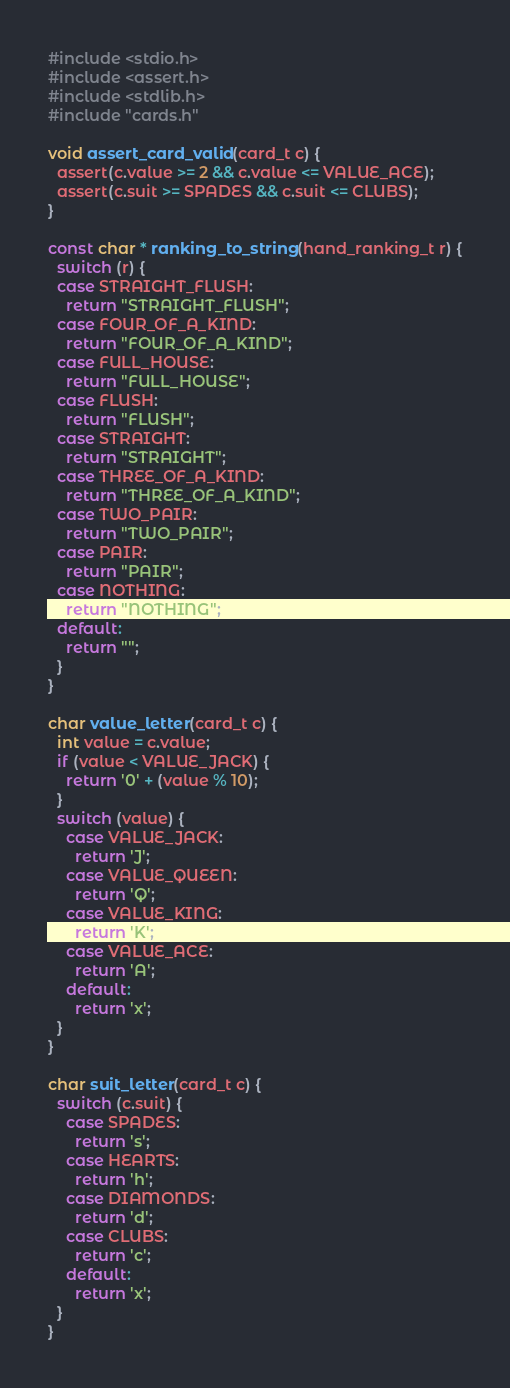Convert code to text. <code><loc_0><loc_0><loc_500><loc_500><_C_>#include <stdio.h>
#include <assert.h>
#include <stdlib.h>
#include "cards.h"

void assert_card_valid(card_t c) {
  assert(c.value >= 2 && c.value <= VALUE_ACE);
  assert(c.suit >= SPADES && c.suit <= CLUBS);
}

const char * ranking_to_string(hand_ranking_t r) {
  switch (r) {
  case STRAIGHT_FLUSH:
    return "STRAIGHT_FLUSH";
  case FOUR_OF_A_KIND:
    return "FOUR_OF_A_KIND";
  case FULL_HOUSE:
    return "FULL_HOUSE";
  case FLUSH:
    return "FLUSH";
  case STRAIGHT:
    return "STRAIGHT";
  case THREE_OF_A_KIND:
    return "THREE_OF_A_KIND";
  case TWO_PAIR:
    return "TWO_PAIR";
  case PAIR:
    return "PAIR";
  case NOTHING:
    return "NOTHING";
  default:
    return "";
  }
}

char value_letter(card_t c) {
  int value = c.value;
  if (value < VALUE_JACK) {
    return '0' + (value % 10);
  }
  switch (value) {
    case VALUE_JACK:
      return 'J';
    case VALUE_QUEEN:
      return 'Q';
    case VALUE_KING:
      return 'K';
    case VALUE_ACE:
      return 'A';
    default:
      return 'x';
  }
}

char suit_letter(card_t c) {
  switch (c.suit) {
    case SPADES:
      return 's';
    case HEARTS:
      return 'h';
    case DIAMONDS:
      return 'd';
    case CLUBS:
      return 'c';
    default:
      return 'x';
  }
}
</code> 